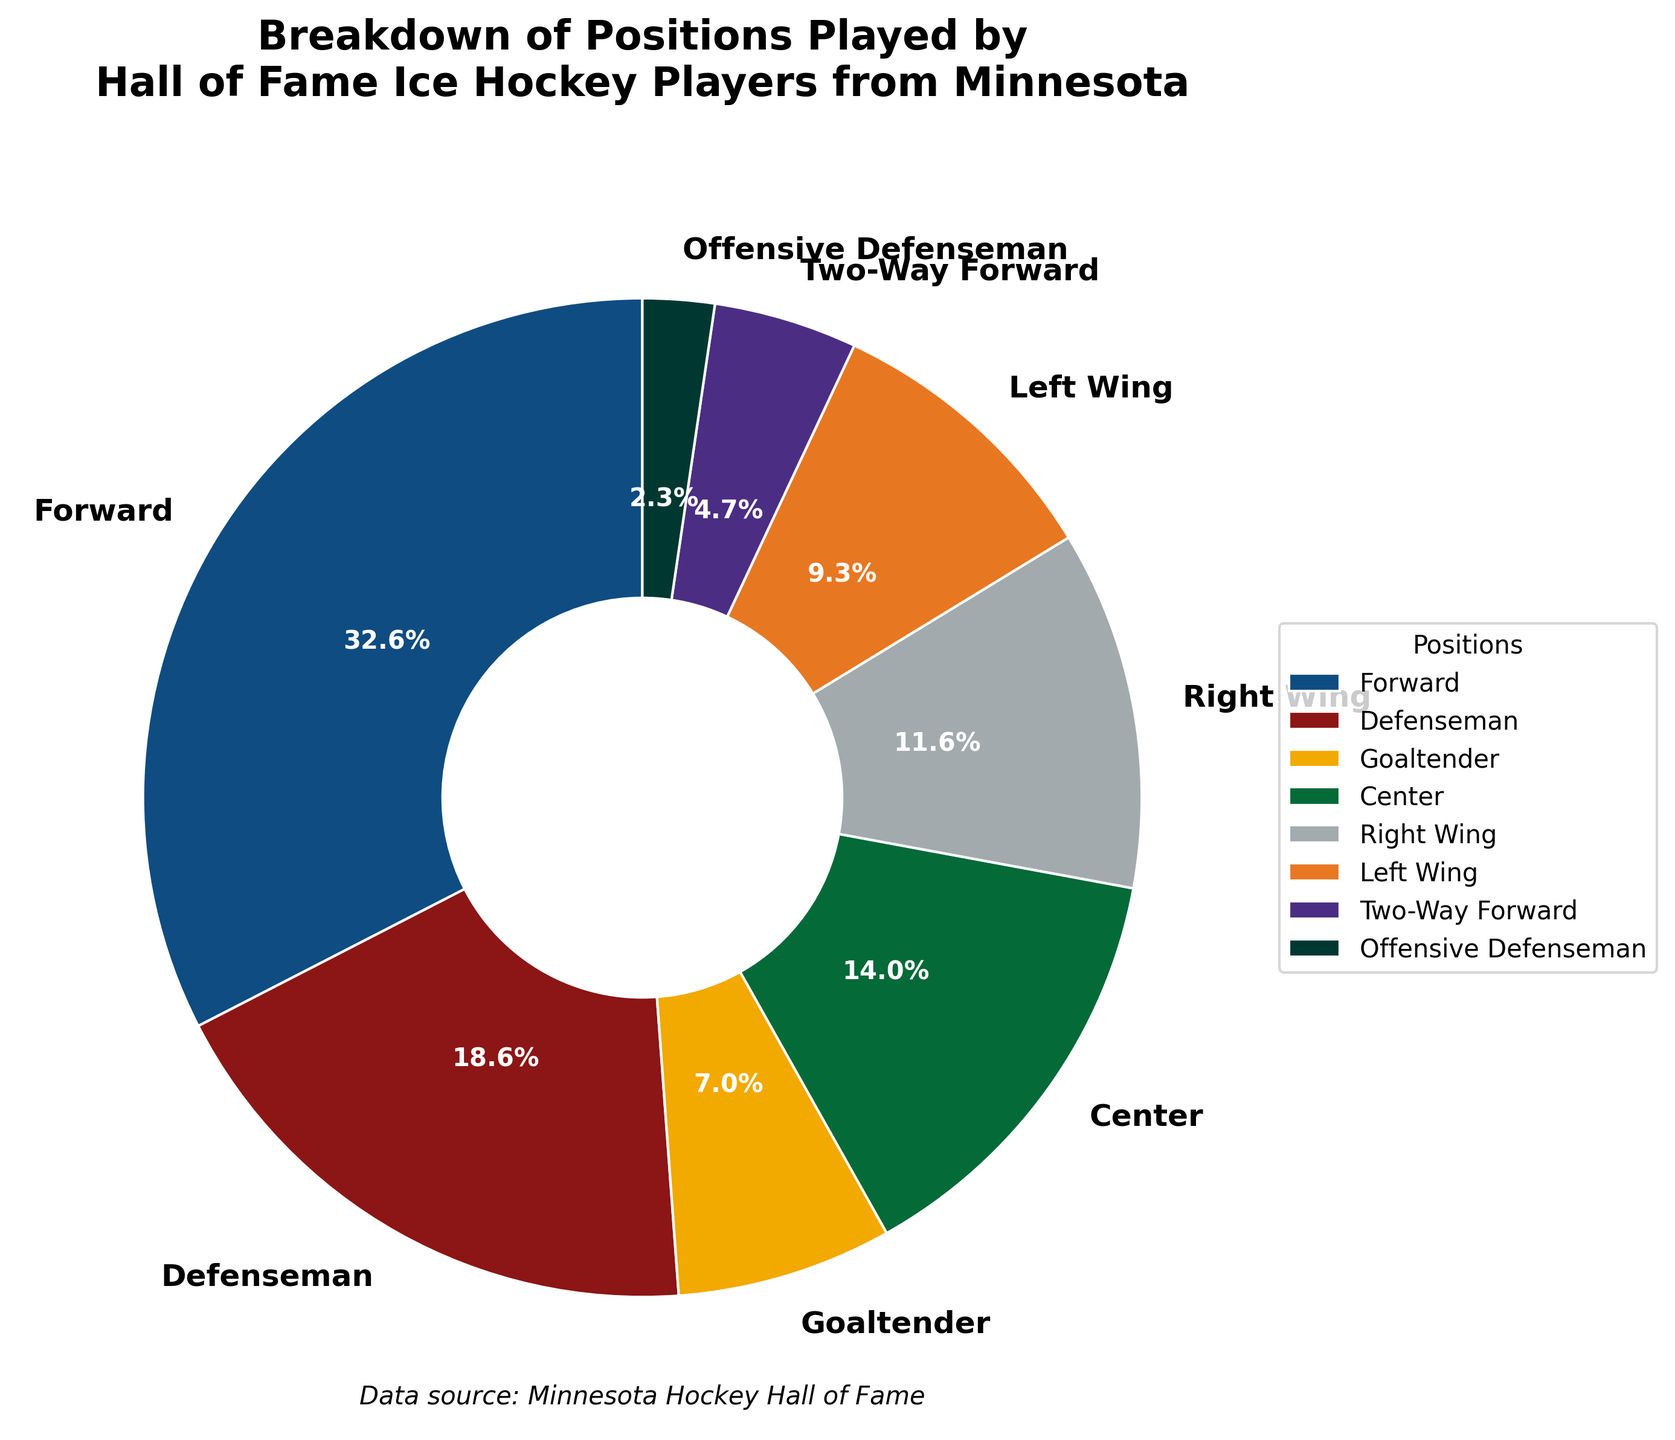What percentage of Hall of Fame ice hockey players from Minnesota were Forwards? The pie chart shows that Forwards make up a segment labeled 14, with a percentage of 38.9% clearly indicated in the segment.
Answer: 38.9% Which position has the fewest Hall of Fame players from Minnesota? The pie chart indicates positions with even small numbers. The segment for Offensive Defenseman is the smallest and labeled with 1 player, making it the fewest.
Answer: Offensive Defenseman How many Hall of Fame players from Minnesota are either Defensemen or Offensive Defensemen? There are 8 Defensemen and 1 Offensive Defenseman. Adding these together gives 8 + 1 = 9.
Answer: 9 Are there more Centers or Goaltenders among Minnesota's Hall of Fame players? The chart shows Centers have a label of 6, whereas Goaltenders have a label of 3. Since 6 is greater than 3, there are more Centers than Goaltenders.
Answer: Centers What portion of the pie is represented by Two-Way Forwards? The Two-Way Forwards segment is labeled 2 and represents 5.6% of the pie chart.
Answer: 5.6% What is the ratio of players that are Forwards to those that are Defensemen? There are 14 Forwards and 8 Defensemen. The ratio of Forwards to Defensemen is 14 to 8, which simplifies to 7 to 4.
Answer: 7:4 Which position group has a larger share: Right Wings or Left Wings? The chart shows Right Wings with 5 players and Left Wings with 4 players. Since 5 is greater than 4, Right Wings have a larger share.
Answer: Right Wings Add the percentage of Goaltenders and Two-Way Forwards. What do you get? The Goaltenders represent 8.3% and Two-Way Forwards represent 5.6%. Adding these together, 8.3% + 5.6% = 13.9%.
Answer: 13.9% What segment is colored with a shade of green? The chart includes a segment marked "Defenseman" which matches one of the Minnesota-themed colors, a shade of green.
Answer: Defenseman Which two positions, when combined, account for more than half of the players? Forwards (38.9%) and Centers (16.7%) make up a combined 55.6%, which is more than half.
Answer: Forwards and Centers 